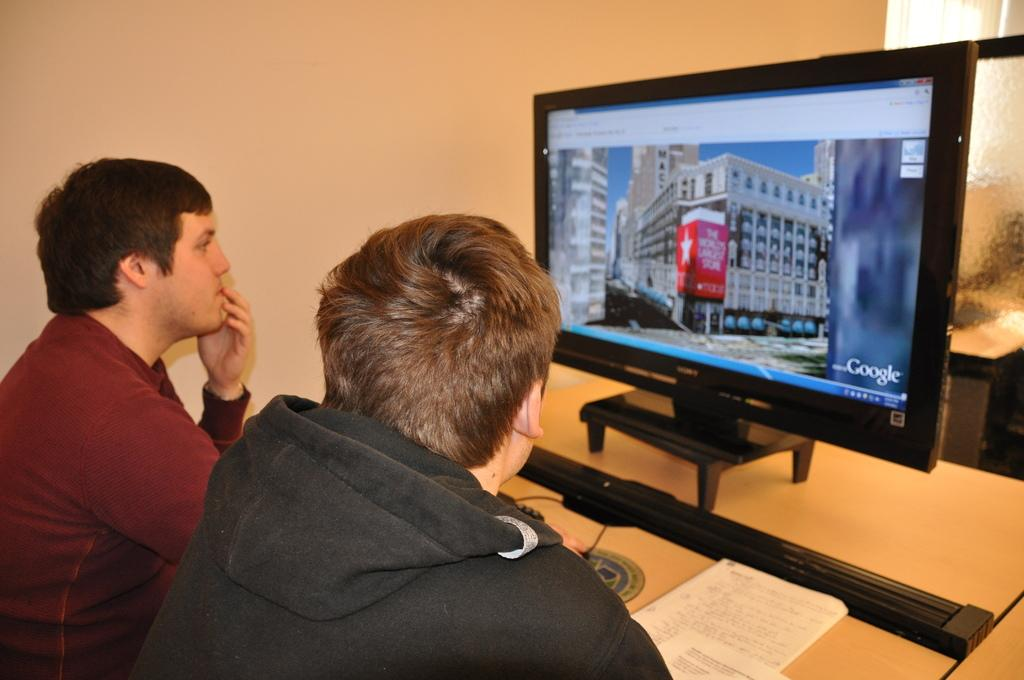<image>
Create a compact narrative representing the image presented. Two guys are looking at an image from Google on a monitor. 